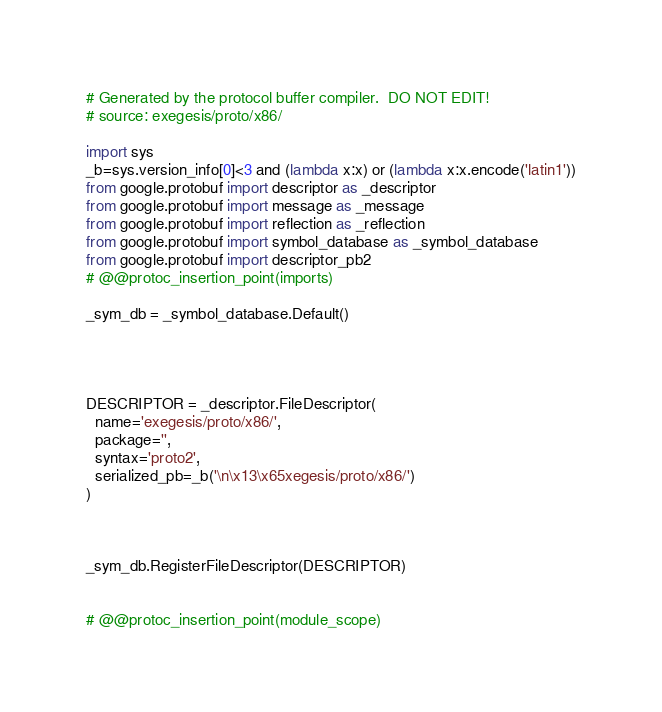Convert code to text. <code><loc_0><loc_0><loc_500><loc_500><_Python_># Generated by the protocol buffer compiler.  DO NOT EDIT!
# source: exegesis/proto/x86/

import sys
_b=sys.version_info[0]<3 and (lambda x:x) or (lambda x:x.encode('latin1'))
from google.protobuf import descriptor as _descriptor
from google.protobuf import message as _message
from google.protobuf import reflection as _reflection
from google.protobuf import symbol_database as _symbol_database
from google.protobuf import descriptor_pb2
# @@protoc_insertion_point(imports)

_sym_db = _symbol_database.Default()




DESCRIPTOR = _descriptor.FileDescriptor(
  name='exegesis/proto/x86/',
  package='',
  syntax='proto2',
  serialized_pb=_b('\n\x13\x65xegesis/proto/x86/')
)



_sym_db.RegisterFileDescriptor(DESCRIPTOR)


# @@protoc_insertion_point(module_scope)
</code> 